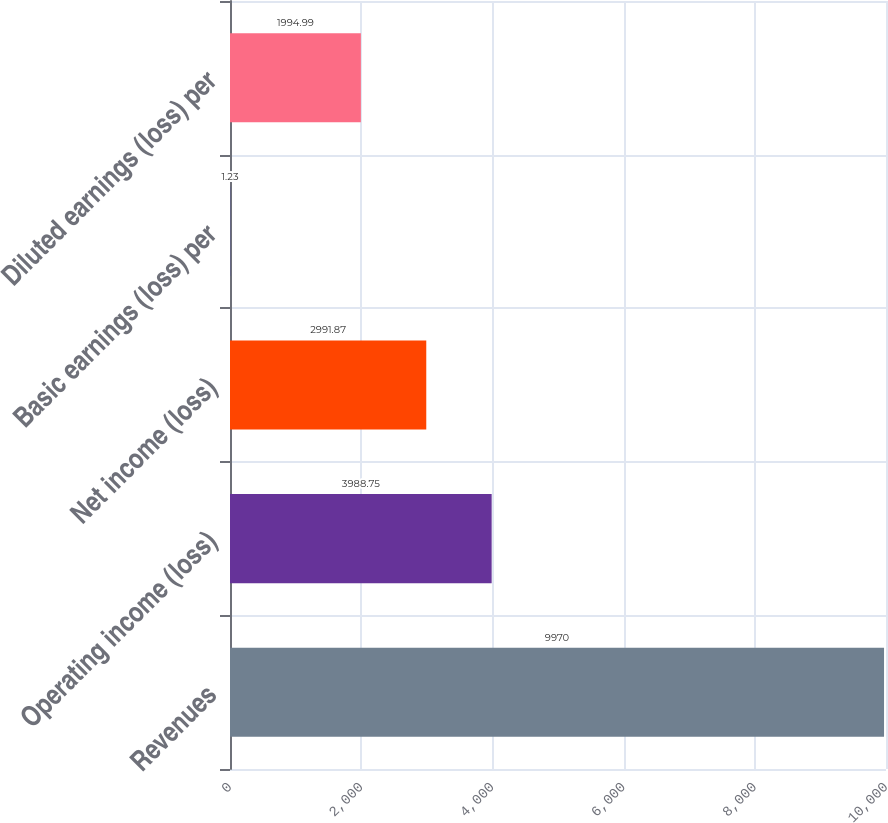Convert chart. <chart><loc_0><loc_0><loc_500><loc_500><bar_chart><fcel>Revenues<fcel>Operating income (loss)<fcel>Net income (loss)<fcel>Basic earnings (loss) per<fcel>Diluted earnings (loss) per<nl><fcel>9970<fcel>3988.75<fcel>2991.87<fcel>1.23<fcel>1994.99<nl></chart> 